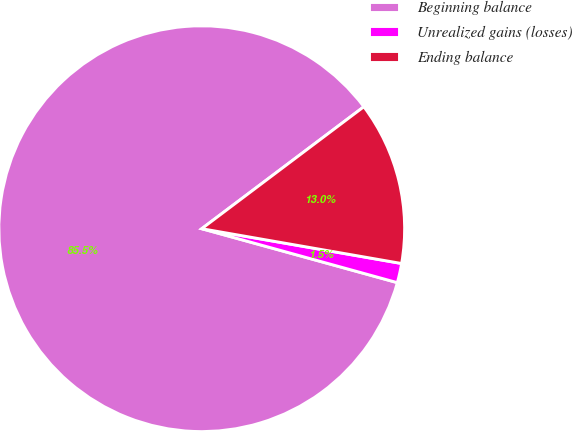<chart> <loc_0><loc_0><loc_500><loc_500><pie_chart><fcel>Beginning balance<fcel>Unrealized gains (losses)<fcel>Ending balance<nl><fcel>85.46%<fcel>1.54%<fcel>13.01%<nl></chart> 